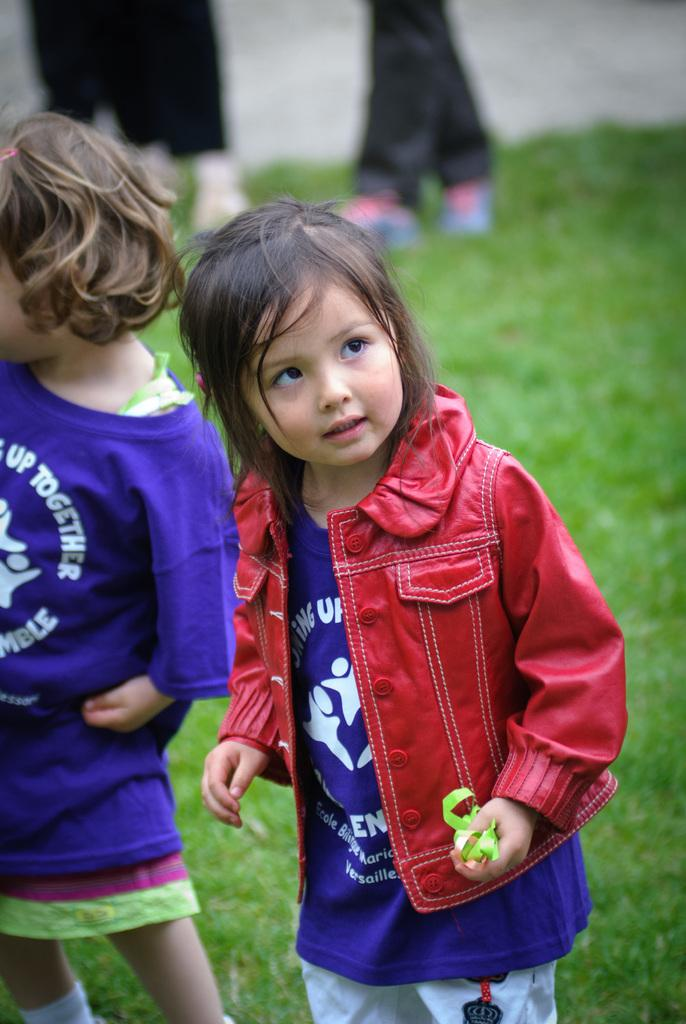How many kids are present in the image? There are two kids in the image. What is the ground made of in the image? The kids are standing on a greenery ground. Can you describe any other people in the image? There are legs of two other persons visible in the background. What type of tomatoes can be seen growing on the plant in the image? There is no tomato plant or tomatoes present in the image. How does the disgusting smell in the image affect the kids? There is no mention of any smell, let alone a disgusting one, in the image. 